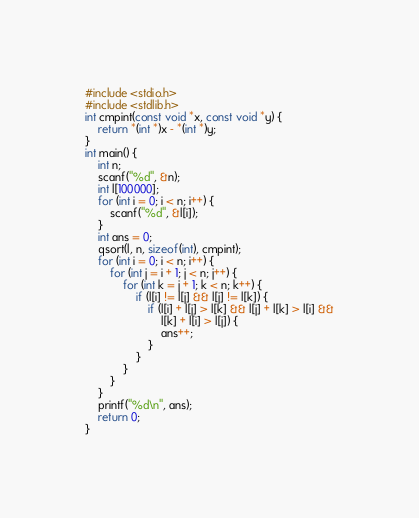<code> <loc_0><loc_0><loc_500><loc_500><_C_>#include <stdio.h>
#include <stdlib.h>
int cmpint(const void *x, const void *y) {
	return *(int *)x - *(int *)y;
}
int main() {
	int n;
	scanf("%d", &n);
	int l[100000];
	for (int i = 0; i < n; i++) {
		scanf("%d", &l[i]);
	}
	int ans = 0;
	qsort(l, n, sizeof(int), cmpint);
	for (int i = 0; i < n; i++) {
		for (int j = i + 1; j < n; j++) {
			for (int k = j + 1; k < n; k++) {
				if (l[i] != l[j] && l[j] != l[k]) {
					if (l[i] + l[j] > l[k] && l[j] + l[k] > l[i] &&
						l[k] + l[i] > l[j]) {
						ans++;
					}
				}
			}
		}
	}
	printf("%d\n", ans);
	return 0;
}</code> 